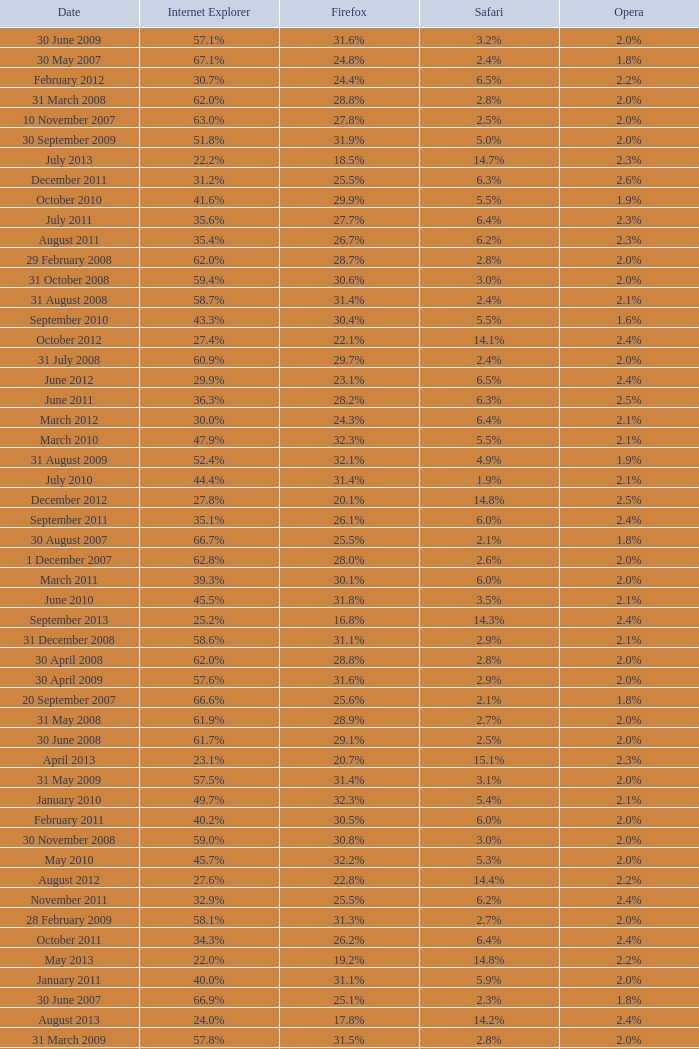What is the safari value with a 28.0% internet explorer? 14.3%. 